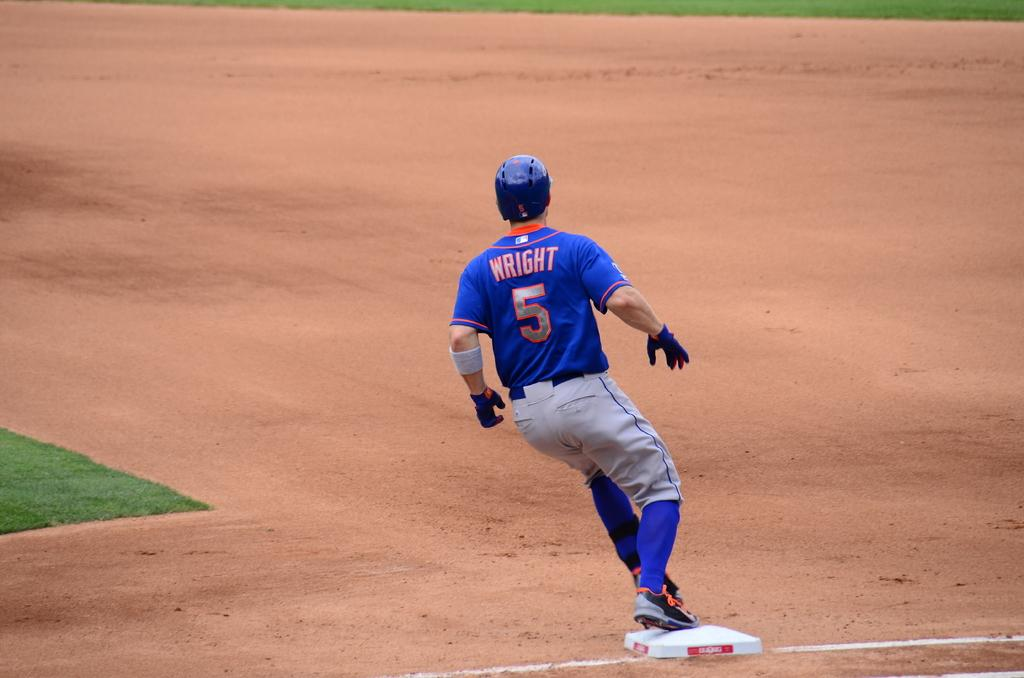<image>
Render a clear and concise summary of the photo. A man is wearing a blue shirt that says "WRIGHT 5" on the back. 